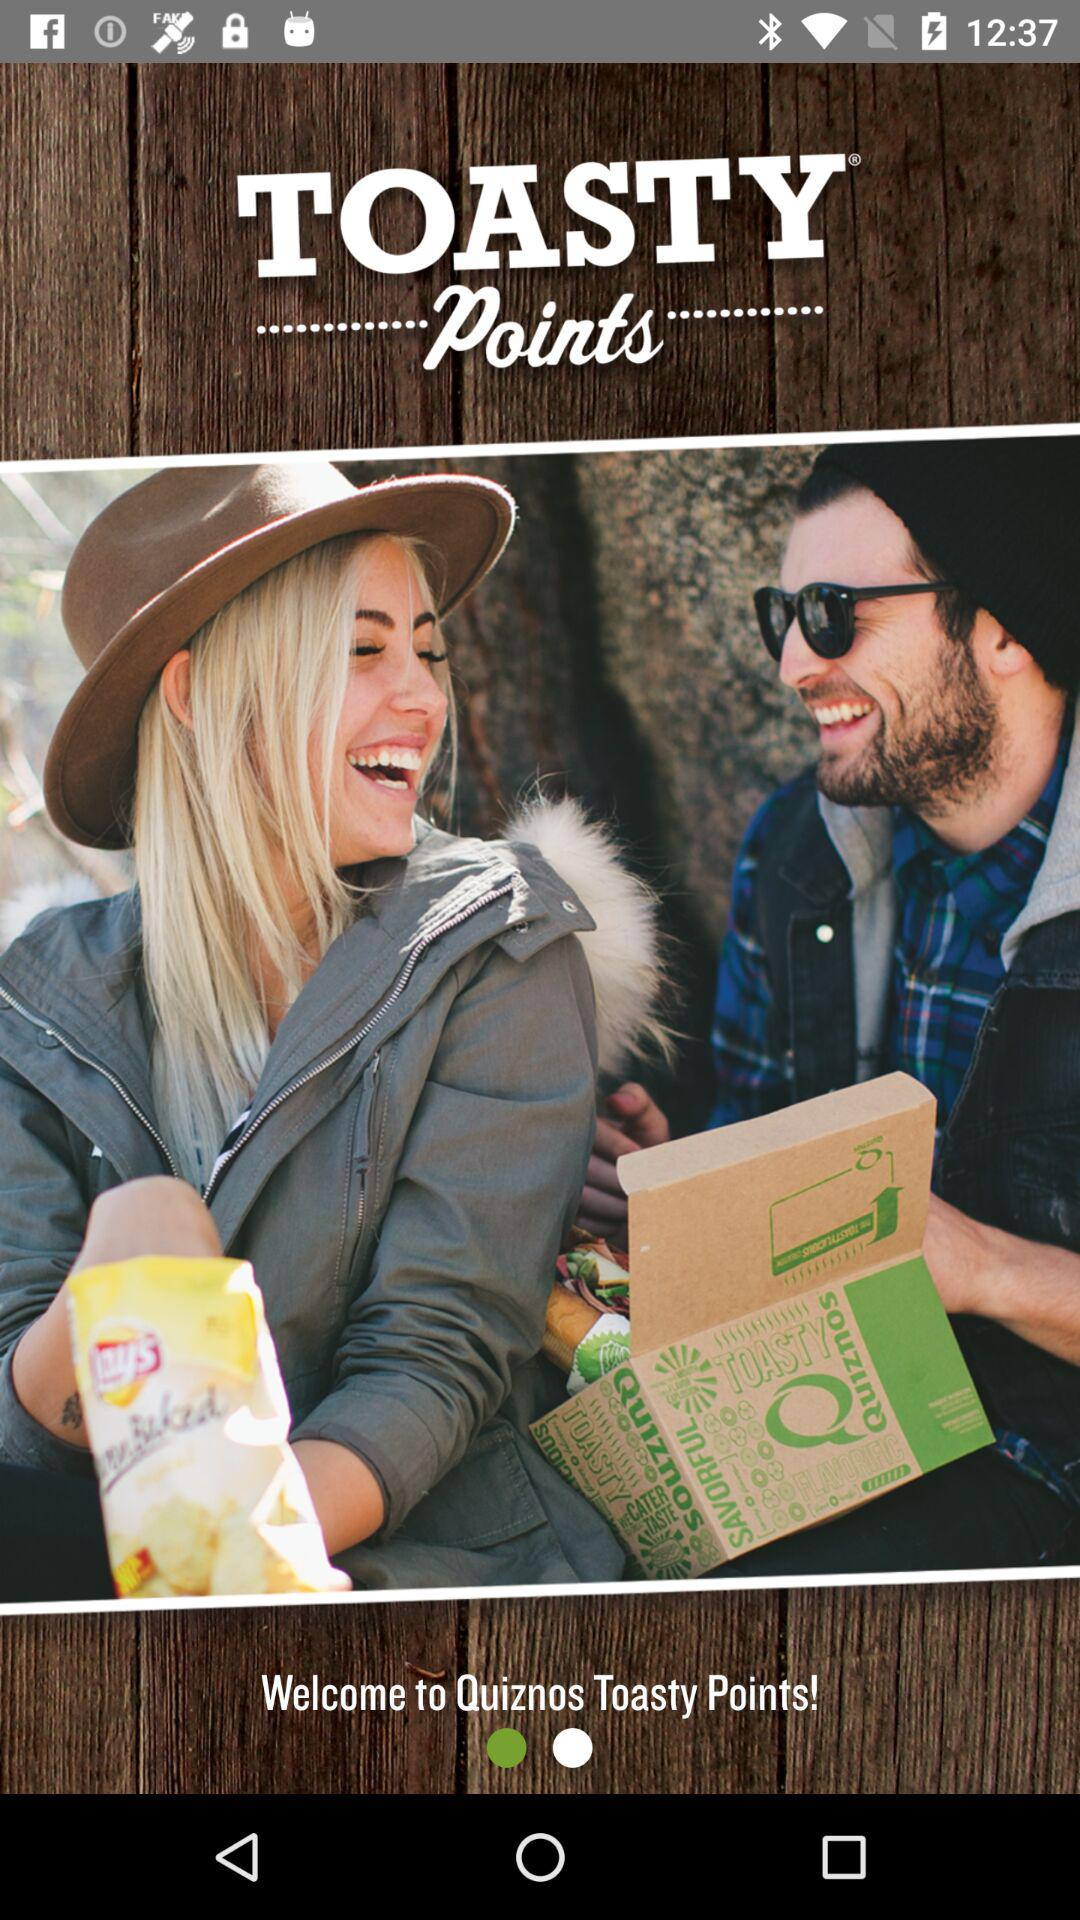What is the name of the application? The name of the application is "Quiznos Toasty Points". 